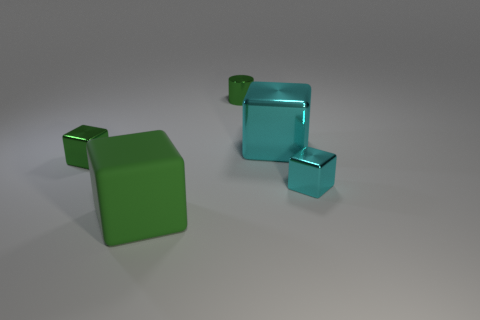The rubber cube is what size?
Keep it short and to the point. Large. Does the green block that is to the left of the large green rubber object have the same size as the green matte thing to the left of the big metallic thing?
Your response must be concise. No. The green matte thing that is the same shape as the large metal thing is what size?
Offer a terse response. Large. There is a rubber block; is its size the same as the cyan block on the left side of the tiny cyan shiny object?
Keep it short and to the point. Yes. There is a tiny cylinder that is to the right of the green rubber object; is there a small cyan thing right of it?
Provide a short and direct response. Yes. The big object that is to the left of the small cylinder has what shape?
Provide a short and direct response. Cube. There is a cylinder that is the same color as the matte block; what material is it?
Give a very brief answer. Metal. What is the color of the metal thing that is to the left of the green object in front of the green shiny cube?
Give a very brief answer. Green. Do the green metal cube and the green cylinder have the same size?
Your response must be concise. Yes. There is a big green thing that is the same shape as the small cyan thing; what material is it?
Give a very brief answer. Rubber. 